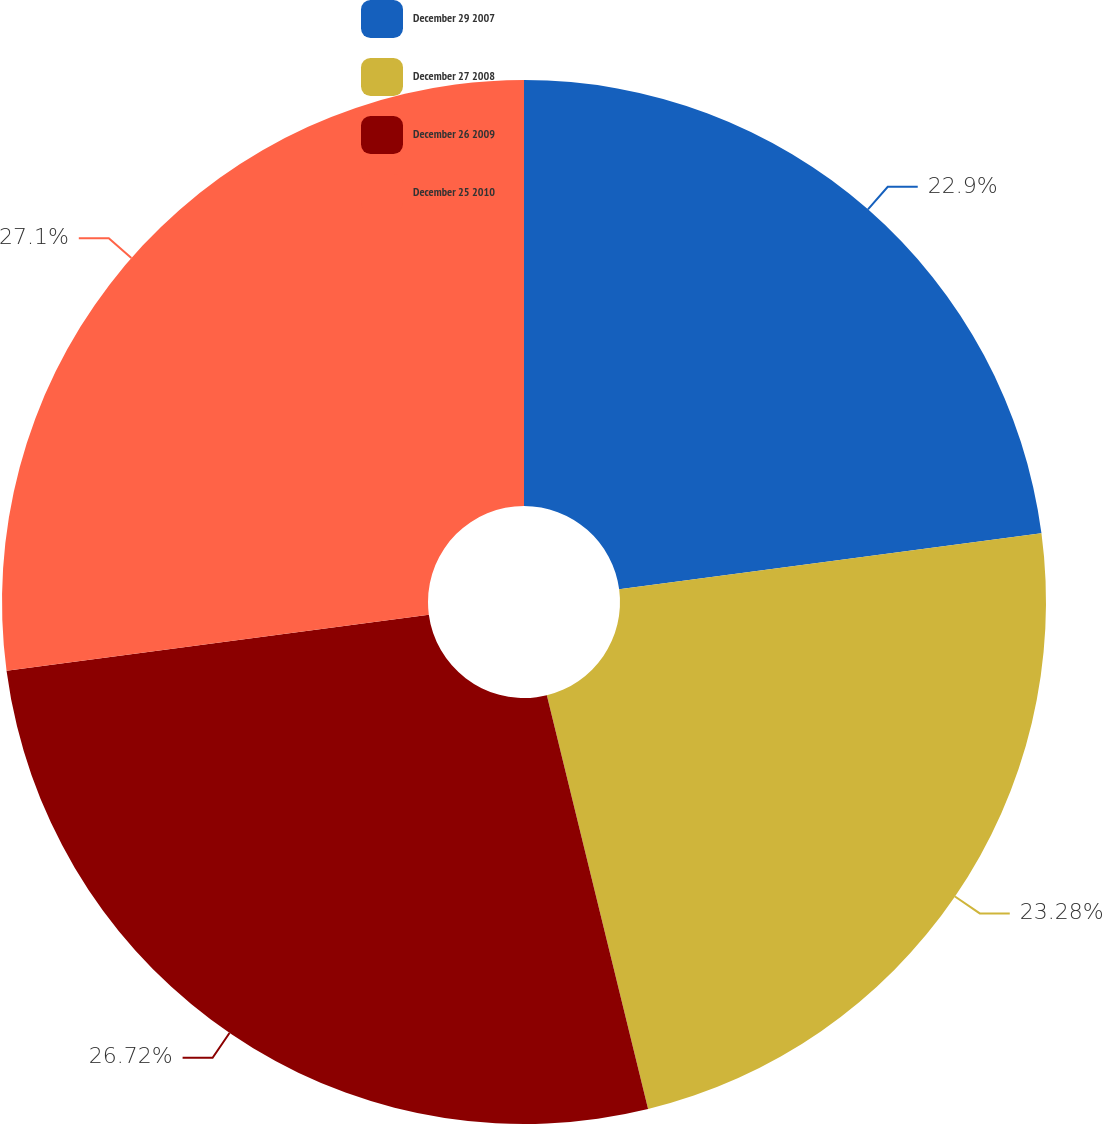Convert chart. <chart><loc_0><loc_0><loc_500><loc_500><pie_chart><fcel>December 29 2007<fcel>December 27 2008<fcel>December 26 2009<fcel>December 25 2010<nl><fcel>22.9%<fcel>23.28%<fcel>26.72%<fcel>27.1%<nl></chart> 